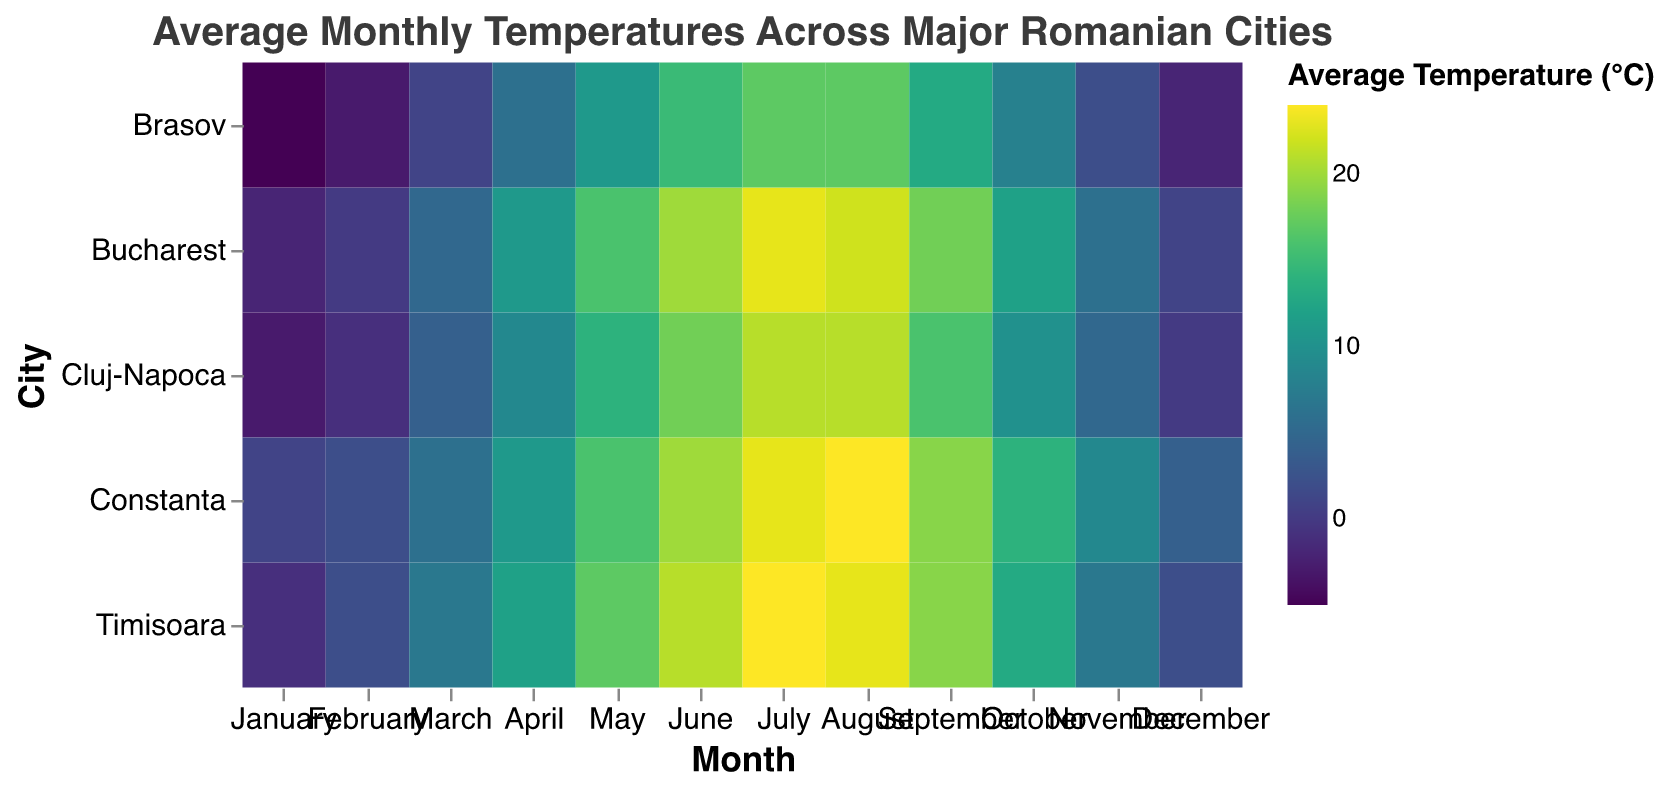What is the average temperature in Bucharest in July? Locate 'Bucharest' on the y-axis and 'July' on the x-axis; the intersecting color represents an average temperature of 23°C.
Answer: 23°C In which month does Brasov have the lowest average temperature? Locate 'Brasov' on the y-axis and find the month with the darkest color, indicating the lowest temperature. It is January with -5°C.
Answer: January Which city has the highest average temperature in August? Locate 'August' on the x-axis and find the corresponding row with the lightest color, indicating the highest temperature. Constanta has the highest at 24°C.
Answer: Constanta How does the average temperature in Cluj-Napoca in March compare to Timisoara in the same month? Find 'March' on the x-axis and compare the colors for 'Cluj-Napoca' and 'Timisoara'. Cluj-Napoca has 4°C, whereas Timisoara has 7°C. Timisoara is warmer.
Answer: Timisoara is warmer Which city has the most consistent average temperature between July and August? Compare the rows for 'July' and 'August' across cities and look for similar colors. Both ’Cluj-Napoca’ and 'Brasov' have the same temperature for both months.
Answer: Cluj-Napoca and Brasov What is the average temperature difference between January and June in Bucharest? Locate 'Bucharest' on the y-axis and find the temperatures for 'January' (`-2°C`) and 'June' (`20°C`). The difference is `20 - (-2)`.
Answer: 22°C In which month does Constanta have the highest average temperature? Locate 'Constanta' on the y-axis and find the month with the lightest color, indicating the highest temperature. It is August at 24°C.
Answer: August How does the average temperature in July compare across all cities? Locate 'July' on the x-axis and compare the colors across all rows. Constanta and Timisoara are the warmest (23°C and 24°C respectively); Brasov is the coolest (17°C).
Answer: Timisoara is the warmest, Brasov is the coolest Between February and November, which city shows the most significant temperature increase? Calculate the difference in temperatures for February and November for each city and compare. Bucharest: `6 - 0 = 6`. Cluj-Napoca: `5 - (-1) = 6`. Timisoara: `7 - 2 = 5`. Brasov: `2 - (-3) = 5`. Constanta: `9 - 2 = 7`. Constanta shows the most significant increase.
Answer: Constanta Which city has the least variation in average temperatures throughout the year? Compare the range (difference between highest and lowest temperatures) for each city by observing the color gradient consistency. Constanta, with temperatures ranging from 1°C to 24°C, shows the least variation.
Answer: Constanta 